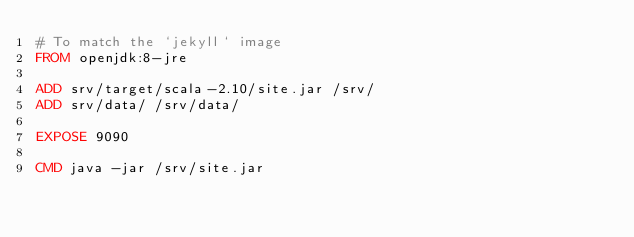<code> <loc_0><loc_0><loc_500><loc_500><_Dockerfile_># To match the `jekyll` image
FROM openjdk:8-jre

ADD srv/target/scala-2.10/site.jar /srv/
ADD srv/data/ /srv/data/

EXPOSE 9090

CMD java -jar /srv/site.jar
</code> 